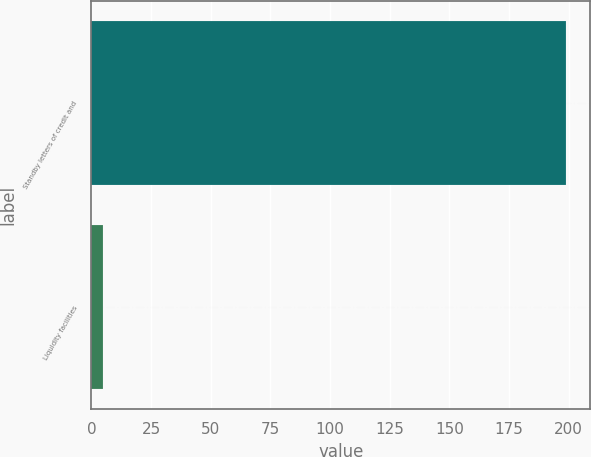Convert chart to OTSL. <chart><loc_0><loc_0><loc_500><loc_500><bar_chart><fcel>Standby letters of credit and<fcel>Liquidity facilities<nl><fcel>199<fcel>5<nl></chart> 